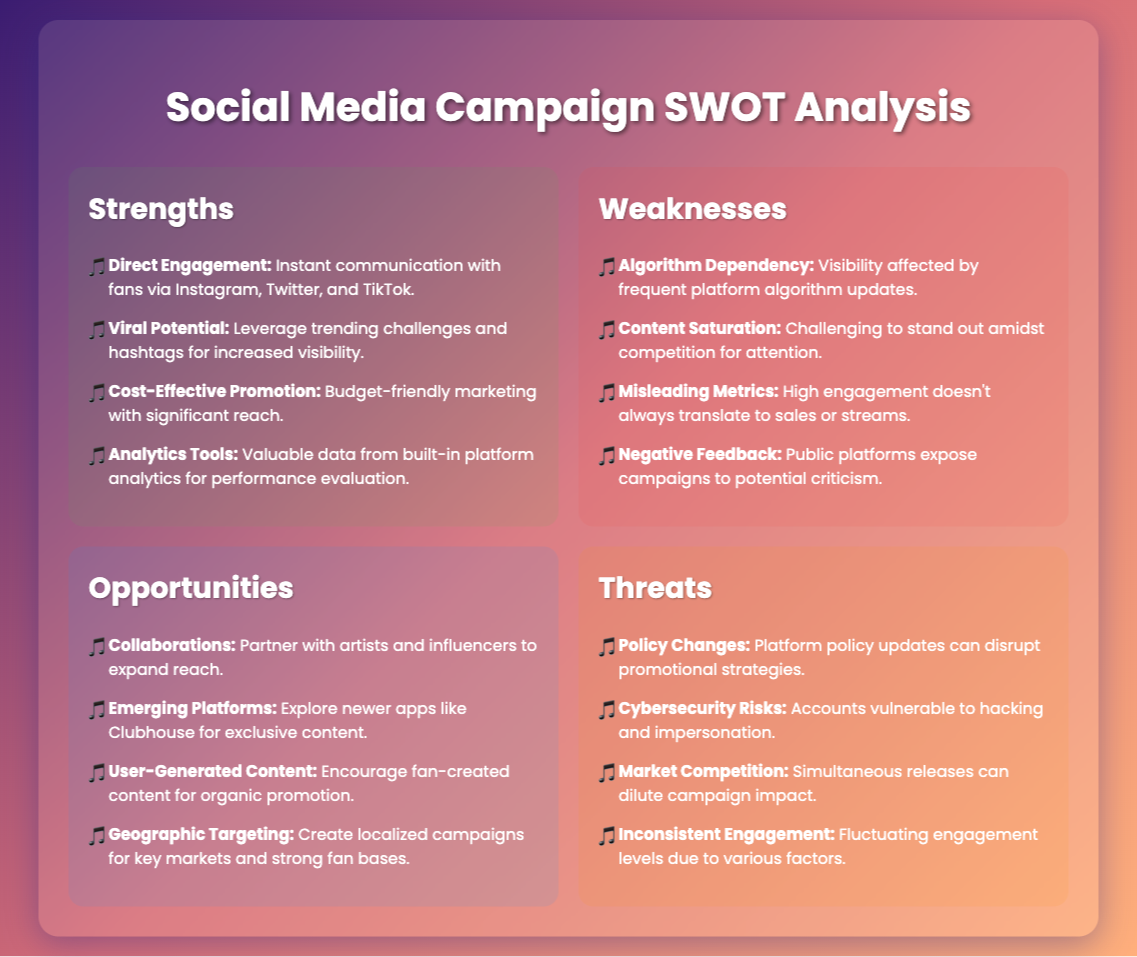what is the main title of the document? The main title of the document is prominently displayed at the top of the page, indicating the subject of the analysis.
Answer: Social Media Campaign SWOT Analysis how many strengths are listed in the document? The document contains a specific section for strengths which lists them out clearly.
Answer: 4 what is one weakness related to social media campaigns mentioned in the document? Insights on weaknesses are provided in the respective section, listing various potential issues.
Answer: Algorithm Dependency what opportunity involves collaborating with others? The document identifies specific avenues for growth under the opportunities section.
Answer: Collaborations name one threat related to social media campaigns. The threats section outlines various risks that can impact the effectiveness of social media engagements.
Answer: Cybersecurity Risks which social media platforms are mentioned for direct engagement? The specific platforms are listed as part of the strengths supporting direct fan interaction.
Answer: Instagram, Twitter, TikTok what percentage of engagement might mislead the artist? A critical aspect of engagement is discussed within the weaknesses, highlighting a specific issue.
Answer: High engagement which platform is mentioned for exploring newer apps? A particular platform is highlighted for its potential in providing exclusive content through the opportunities.
Answer: Clubhouse 